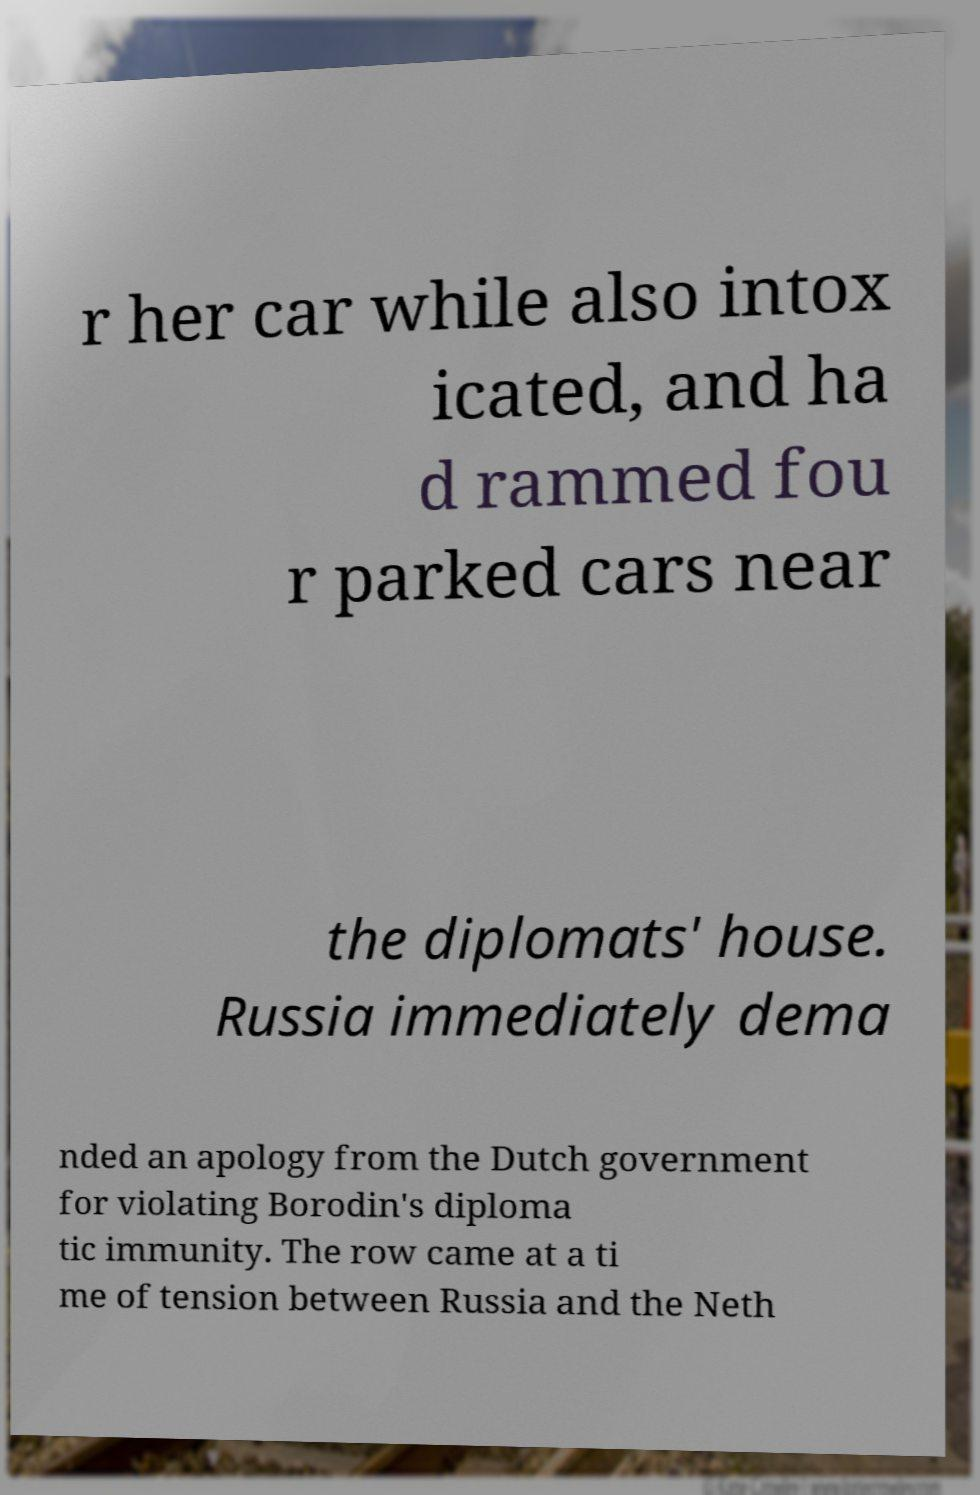There's text embedded in this image that I need extracted. Can you transcribe it verbatim? r her car while also intox icated, and ha d rammed fou r parked cars near the diplomats' house. Russia immediately dema nded an apology from the Dutch government for violating Borodin's diploma tic immunity. The row came at a ti me of tension between Russia and the Neth 